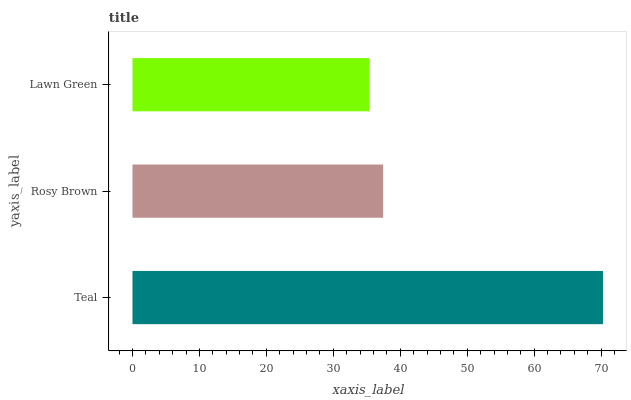Is Lawn Green the minimum?
Answer yes or no. Yes. Is Teal the maximum?
Answer yes or no. Yes. Is Rosy Brown the minimum?
Answer yes or no. No. Is Rosy Brown the maximum?
Answer yes or no. No. Is Teal greater than Rosy Brown?
Answer yes or no. Yes. Is Rosy Brown less than Teal?
Answer yes or no. Yes. Is Rosy Brown greater than Teal?
Answer yes or no. No. Is Teal less than Rosy Brown?
Answer yes or no. No. Is Rosy Brown the high median?
Answer yes or no. Yes. Is Rosy Brown the low median?
Answer yes or no. Yes. Is Lawn Green the high median?
Answer yes or no. No. Is Lawn Green the low median?
Answer yes or no. No. 